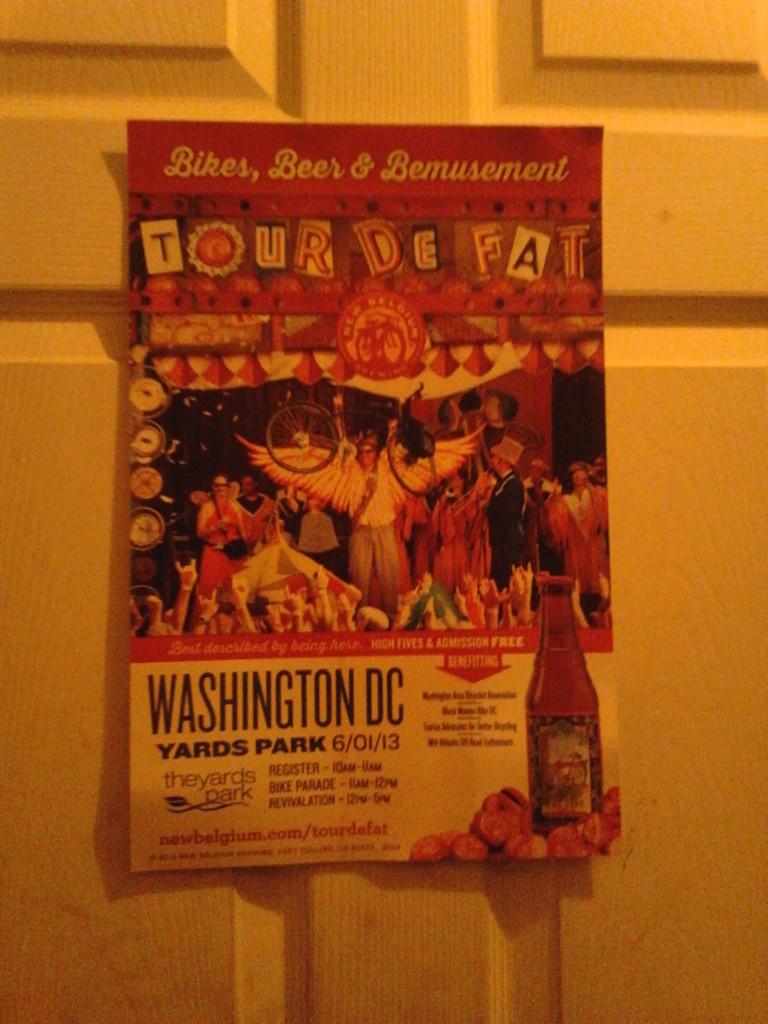What word is after 'beer &'?
Provide a succinct answer. Bemusement. What is the name of this event?
Ensure brevity in your answer.  Tour de fat. 